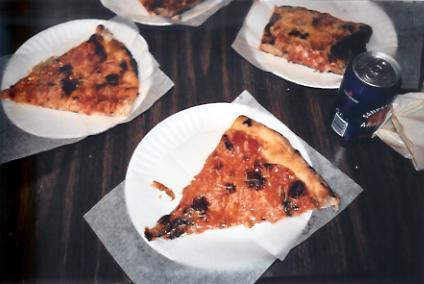How many pieces of square pizza are in this picture?
Give a very brief answer. 1. How many dining tables are visible?
Give a very brief answer. 1. How many pizzas are there?
Give a very brief answer. 3. 